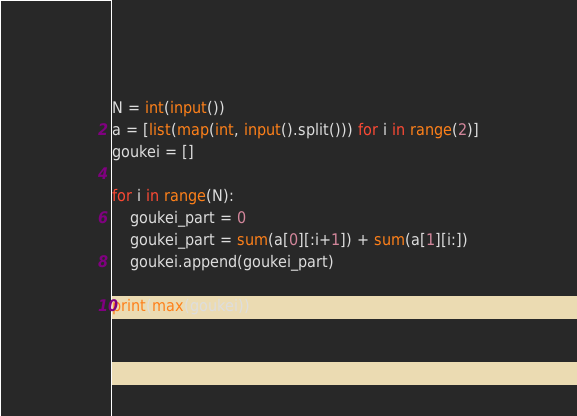<code> <loc_0><loc_0><loc_500><loc_500><_Python_>N = int(input())
a = [list(map(int, input().split())) for i in range(2)]
goukei = []

for i in range(N):
    goukei_part = 0
    goukei_part = sum(a[0][:i+1]) + sum(a[1][i:])
    goukei.append(goukei_part)

print(max(goukei))
</code> 